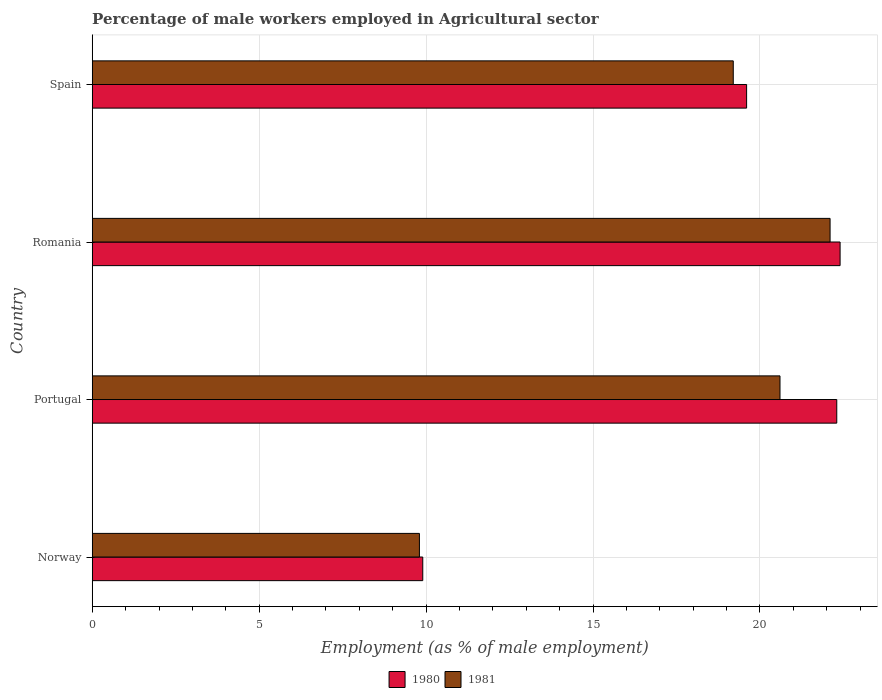How many groups of bars are there?
Offer a terse response. 4. Are the number of bars on each tick of the Y-axis equal?
Make the answer very short. Yes. How many bars are there on the 3rd tick from the top?
Provide a short and direct response. 2. What is the label of the 3rd group of bars from the top?
Give a very brief answer. Portugal. In how many cases, is the number of bars for a given country not equal to the number of legend labels?
Provide a short and direct response. 0. What is the percentage of male workers employed in Agricultural sector in 1980 in Portugal?
Ensure brevity in your answer.  22.3. Across all countries, what is the maximum percentage of male workers employed in Agricultural sector in 1980?
Give a very brief answer. 22.4. Across all countries, what is the minimum percentage of male workers employed in Agricultural sector in 1980?
Your response must be concise. 9.9. In which country was the percentage of male workers employed in Agricultural sector in 1980 maximum?
Keep it short and to the point. Romania. In which country was the percentage of male workers employed in Agricultural sector in 1980 minimum?
Keep it short and to the point. Norway. What is the total percentage of male workers employed in Agricultural sector in 1980 in the graph?
Give a very brief answer. 74.2. What is the difference between the percentage of male workers employed in Agricultural sector in 1981 in Norway and that in Portugal?
Offer a very short reply. -10.8. What is the difference between the percentage of male workers employed in Agricultural sector in 1980 in Romania and the percentage of male workers employed in Agricultural sector in 1981 in Norway?
Your answer should be compact. 12.6. What is the average percentage of male workers employed in Agricultural sector in 1981 per country?
Your answer should be compact. 17.93. What is the difference between the percentage of male workers employed in Agricultural sector in 1980 and percentage of male workers employed in Agricultural sector in 1981 in Norway?
Offer a terse response. 0.1. What is the ratio of the percentage of male workers employed in Agricultural sector in 1981 in Norway to that in Romania?
Your response must be concise. 0.44. Is the difference between the percentage of male workers employed in Agricultural sector in 1980 in Portugal and Spain greater than the difference between the percentage of male workers employed in Agricultural sector in 1981 in Portugal and Spain?
Your answer should be very brief. Yes. What is the difference between the highest and the second highest percentage of male workers employed in Agricultural sector in 1980?
Offer a very short reply. 0.1. What is the difference between the highest and the lowest percentage of male workers employed in Agricultural sector in 1980?
Give a very brief answer. 12.5. Is the sum of the percentage of male workers employed in Agricultural sector in 1980 in Norway and Portugal greater than the maximum percentage of male workers employed in Agricultural sector in 1981 across all countries?
Provide a succinct answer. Yes. What does the 2nd bar from the top in Romania represents?
Offer a terse response. 1980. What does the 2nd bar from the bottom in Portugal represents?
Offer a terse response. 1981. How many bars are there?
Your answer should be very brief. 8. Are all the bars in the graph horizontal?
Keep it short and to the point. Yes. How many countries are there in the graph?
Make the answer very short. 4. Does the graph contain any zero values?
Your answer should be very brief. No. Does the graph contain grids?
Your answer should be very brief. Yes. How many legend labels are there?
Keep it short and to the point. 2. How are the legend labels stacked?
Make the answer very short. Horizontal. What is the title of the graph?
Your answer should be compact. Percentage of male workers employed in Agricultural sector. Does "1970" appear as one of the legend labels in the graph?
Keep it short and to the point. No. What is the label or title of the X-axis?
Your response must be concise. Employment (as % of male employment). What is the label or title of the Y-axis?
Your answer should be very brief. Country. What is the Employment (as % of male employment) in 1980 in Norway?
Ensure brevity in your answer.  9.9. What is the Employment (as % of male employment) in 1981 in Norway?
Your answer should be compact. 9.8. What is the Employment (as % of male employment) in 1980 in Portugal?
Keep it short and to the point. 22.3. What is the Employment (as % of male employment) in 1981 in Portugal?
Offer a terse response. 20.6. What is the Employment (as % of male employment) in 1980 in Romania?
Provide a short and direct response. 22.4. What is the Employment (as % of male employment) in 1981 in Romania?
Your answer should be very brief. 22.1. What is the Employment (as % of male employment) of 1980 in Spain?
Keep it short and to the point. 19.6. What is the Employment (as % of male employment) in 1981 in Spain?
Make the answer very short. 19.2. Across all countries, what is the maximum Employment (as % of male employment) of 1980?
Give a very brief answer. 22.4. Across all countries, what is the maximum Employment (as % of male employment) of 1981?
Keep it short and to the point. 22.1. Across all countries, what is the minimum Employment (as % of male employment) of 1980?
Your response must be concise. 9.9. Across all countries, what is the minimum Employment (as % of male employment) of 1981?
Offer a very short reply. 9.8. What is the total Employment (as % of male employment) of 1980 in the graph?
Ensure brevity in your answer.  74.2. What is the total Employment (as % of male employment) of 1981 in the graph?
Offer a terse response. 71.7. What is the difference between the Employment (as % of male employment) in 1981 in Norway and that in Romania?
Your answer should be very brief. -12.3. What is the difference between the Employment (as % of male employment) in 1980 in Norway and the Employment (as % of male employment) in 1981 in Portugal?
Provide a succinct answer. -10.7. What is the difference between the Employment (as % of male employment) of 1980 in Norway and the Employment (as % of male employment) of 1981 in Romania?
Ensure brevity in your answer.  -12.2. What is the difference between the Employment (as % of male employment) of 1980 in Norway and the Employment (as % of male employment) of 1981 in Spain?
Your response must be concise. -9.3. What is the difference between the Employment (as % of male employment) of 1980 in Portugal and the Employment (as % of male employment) of 1981 in Romania?
Your answer should be compact. 0.2. What is the average Employment (as % of male employment) in 1980 per country?
Offer a very short reply. 18.55. What is the average Employment (as % of male employment) of 1981 per country?
Your answer should be very brief. 17.93. What is the ratio of the Employment (as % of male employment) in 1980 in Norway to that in Portugal?
Provide a succinct answer. 0.44. What is the ratio of the Employment (as % of male employment) in 1981 in Norway to that in Portugal?
Provide a short and direct response. 0.48. What is the ratio of the Employment (as % of male employment) in 1980 in Norway to that in Romania?
Ensure brevity in your answer.  0.44. What is the ratio of the Employment (as % of male employment) in 1981 in Norway to that in Romania?
Ensure brevity in your answer.  0.44. What is the ratio of the Employment (as % of male employment) of 1980 in Norway to that in Spain?
Keep it short and to the point. 0.51. What is the ratio of the Employment (as % of male employment) of 1981 in Norway to that in Spain?
Offer a very short reply. 0.51. What is the ratio of the Employment (as % of male employment) in 1980 in Portugal to that in Romania?
Provide a succinct answer. 1. What is the ratio of the Employment (as % of male employment) of 1981 in Portugal to that in Romania?
Ensure brevity in your answer.  0.93. What is the ratio of the Employment (as % of male employment) of 1980 in Portugal to that in Spain?
Offer a terse response. 1.14. What is the ratio of the Employment (as % of male employment) in 1981 in Portugal to that in Spain?
Keep it short and to the point. 1.07. What is the ratio of the Employment (as % of male employment) of 1981 in Romania to that in Spain?
Ensure brevity in your answer.  1.15. What is the difference between the highest and the second highest Employment (as % of male employment) of 1981?
Your answer should be compact. 1.5. What is the difference between the highest and the lowest Employment (as % of male employment) of 1980?
Offer a terse response. 12.5. 